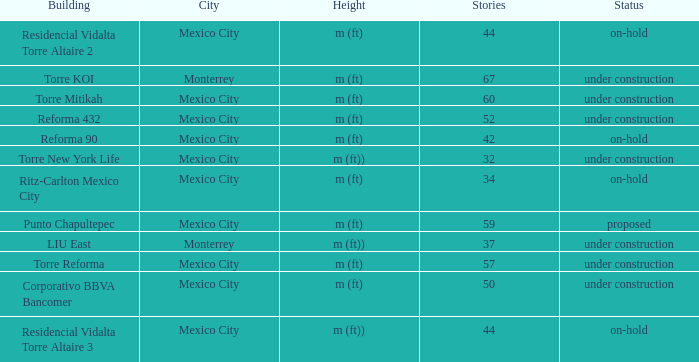How many stories is the torre reforma building? 1.0. 